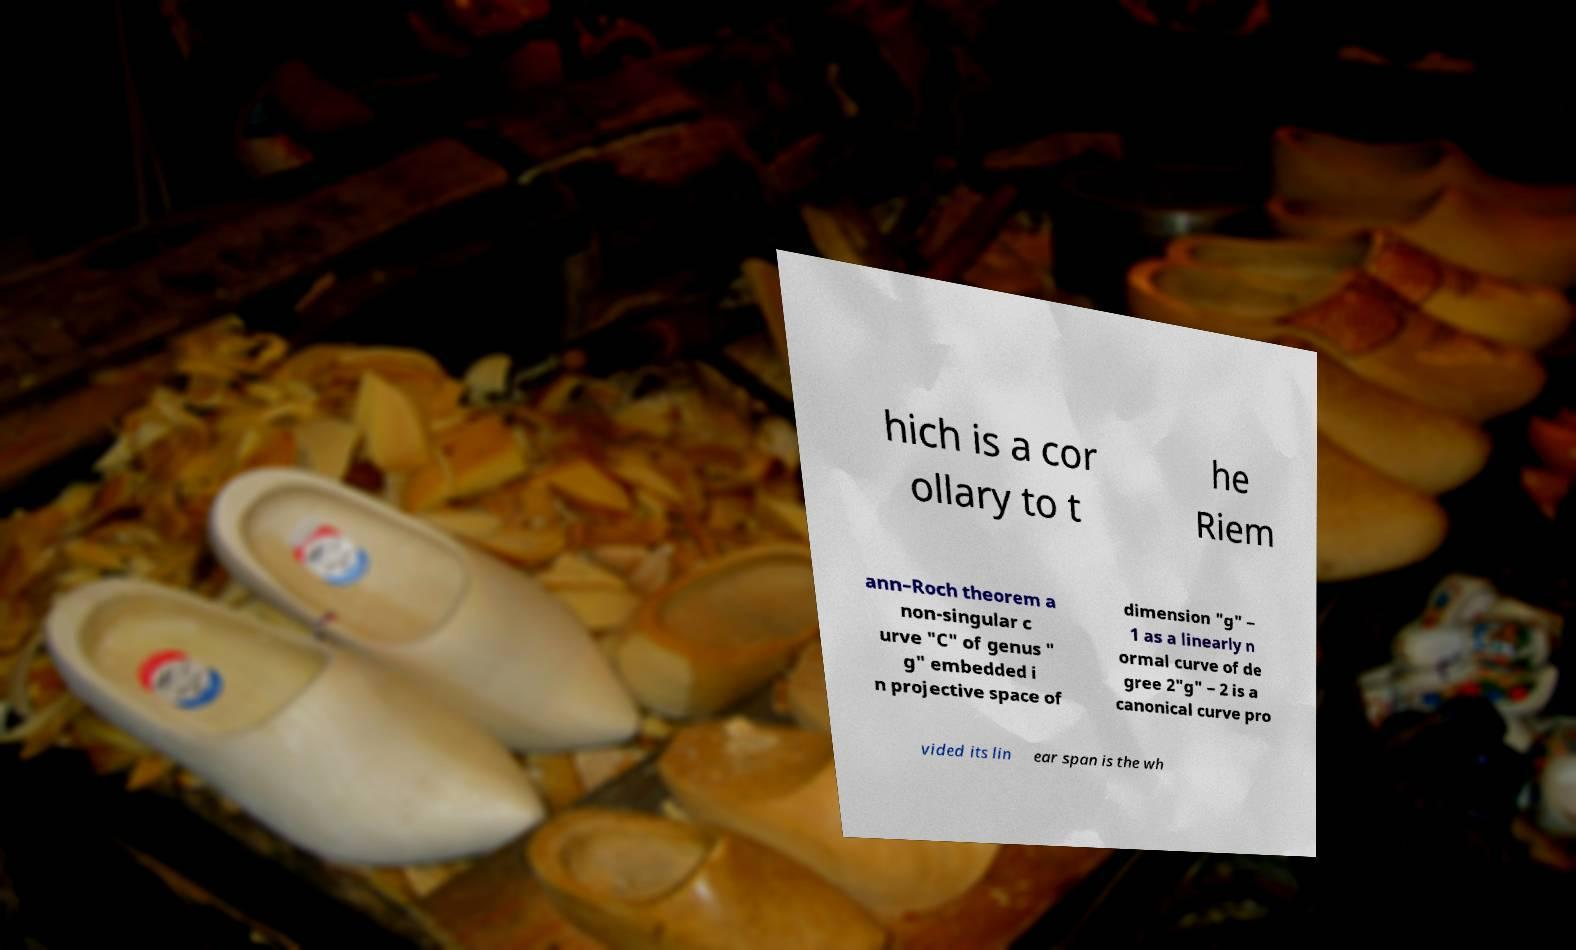For documentation purposes, I need the text within this image transcribed. Could you provide that? hich is a cor ollary to t he Riem ann–Roch theorem a non-singular c urve "C" of genus " g" embedded i n projective space of dimension "g" − 1 as a linearly n ormal curve of de gree 2"g" − 2 is a canonical curve pro vided its lin ear span is the wh 